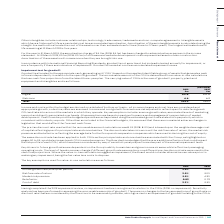According to Auto Trader's financial document, What are the key drivers to future growth rates dependent on? the Group’s ability to maintain and grow income streams whilst effectively managing operating costs. The document states: "y drivers to future growth rates are dependent on the Group’s ability to maintain and grow income streams whilst effectively managing operating costs...." Also, In what situations might the level of headroom change? if different growth rate assumptions or a different pre-tax discount rate were used in the cash flow projections. The document states: "operating costs. The level of headroom may change if different growth rate assumptions or a different pre-tax discount rate were used in the cash flow..." Also, What are the key assumptions used for value-in-use calculations in the table? The document contains multiple relevant values: Annual growth rate (after plan period), Risk free rate of return, Market risk premium, Beta factor, Cost of debt. From the document: "Beta factor 0.83 0.79 Risk free rate of return 3.0% 3.0% Annual growth rate (after plan period) 3.0% 3.0% Cost of debt 3.3% 3.3% Market risk premium 5..." Additionally, In which year was the market risk premium percentage larger? According to the financial document, 2019. The relevant text states: "2019 2018..." Also, can you calculate: What was the change in the Beta factor in 2019 from 2018? Based on the calculation: 0.83-0.79, the result is 0.04. This is based on the information: "Beta factor 0.83 0.79 Beta factor 0.83 0.79..." The key data points involved are: 0.79, 0.83. Also, can you calculate: What was the percentage change in the Beta factor in 2019 from 2018? To answer this question, I need to perform calculations using the financial data. The calculation is: (0.83-0.79)/0.79, which equals 5.06 (percentage). This is based on the information: "Beta factor 0.83 0.79 Beta factor 0.83 0.79..." The key data points involved are: 0.79, 0.83. 